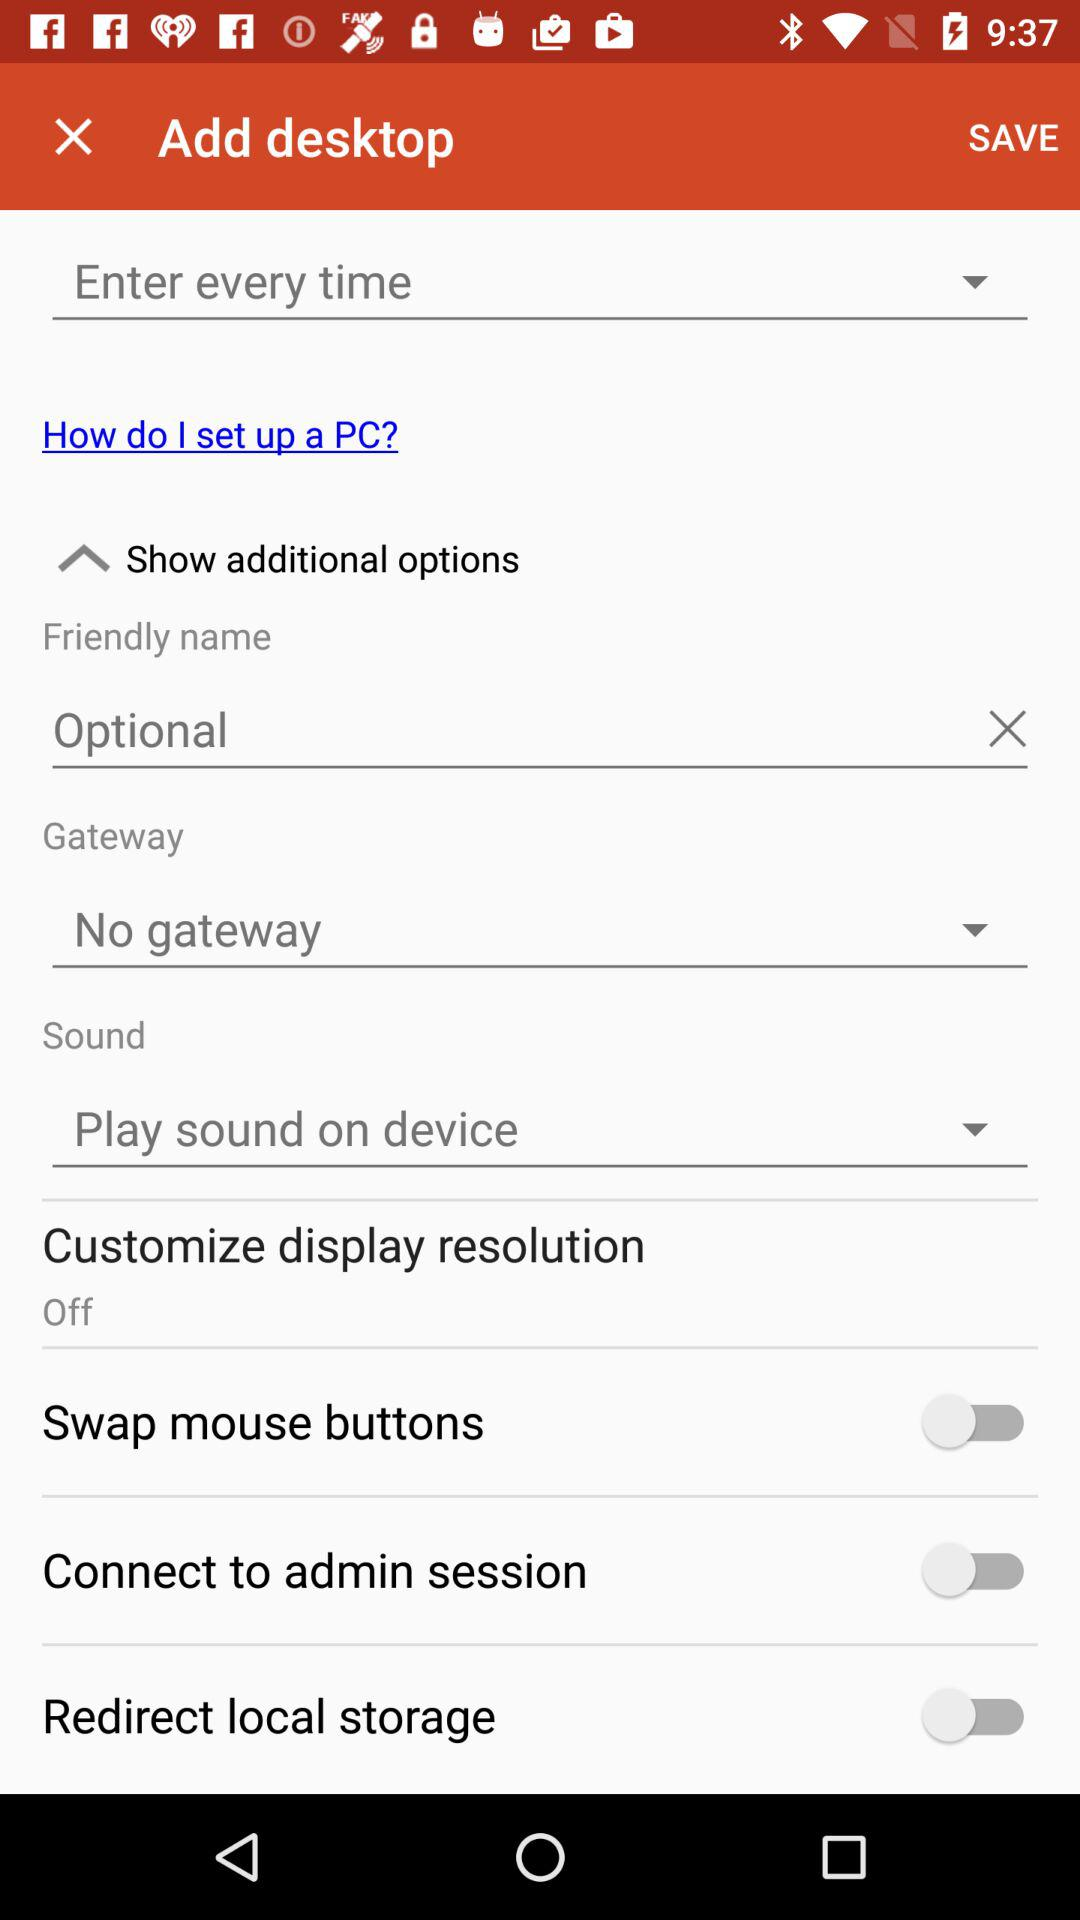What is selected in the "Friendly name"? In the "Friendly name", "Optional" is selected. 